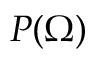<formula> <loc_0><loc_0><loc_500><loc_500>P ( \Omega )</formula> 